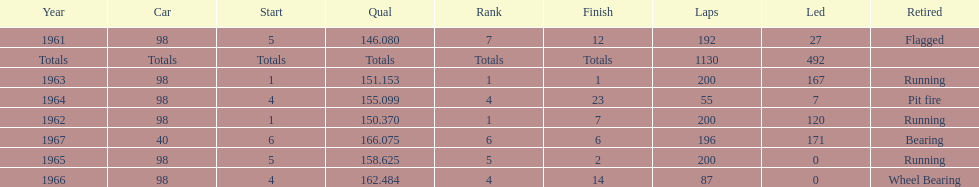What car achieved the highest qual? 40. 